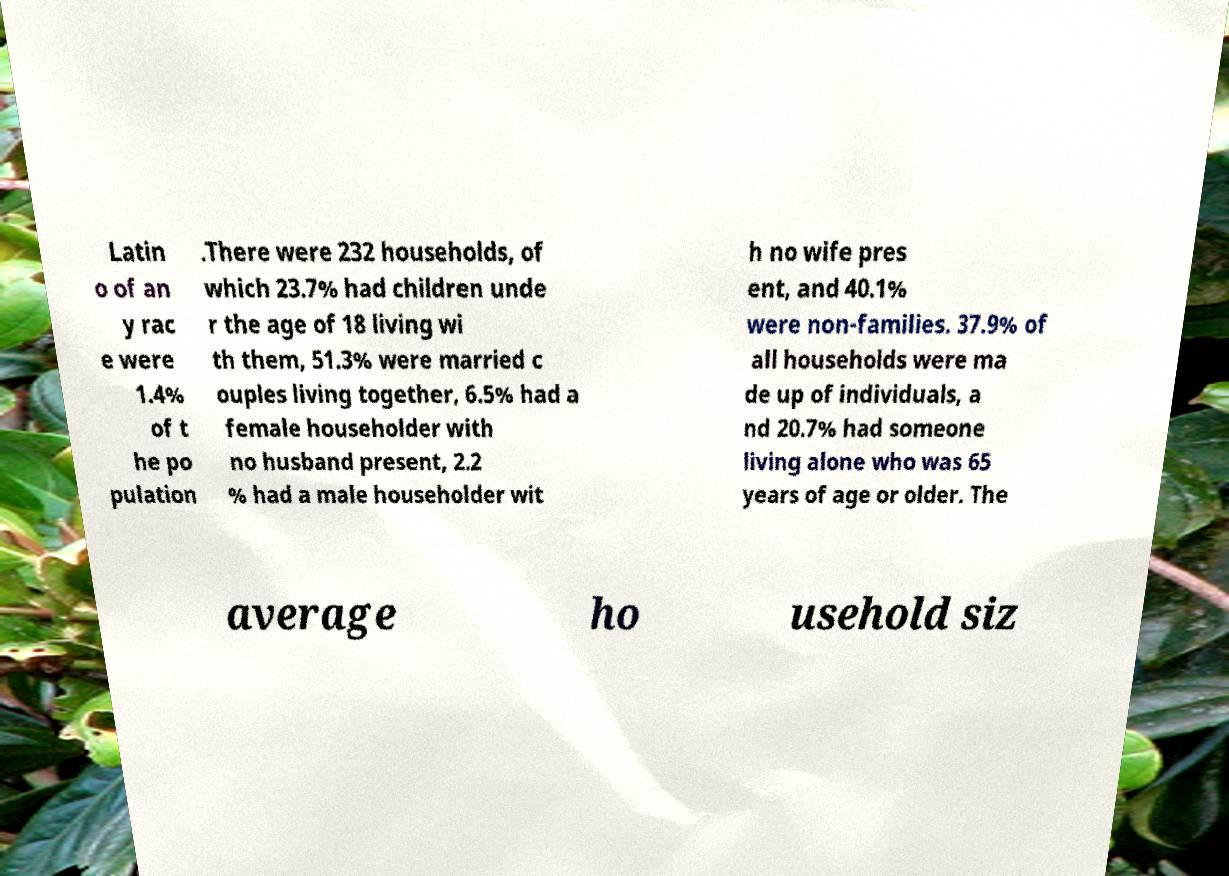Can you read and provide the text displayed in the image?This photo seems to have some interesting text. Can you extract and type it out for me? Latin o of an y rac e were 1.4% of t he po pulation .There were 232 households, of which 23.7% had children unde r the age of 18 living wi th them, 51.3% were married c ouples living together, 6.5% had a female householder with no husband present, 2.2 % had a male householder wit h no wife pres ent, and 40.1% were non-families. 37.9% of all households were ma de up of individuals, a nd 20.7% had someone living alone who was 65 years of age or older. The average ho usehold siz 